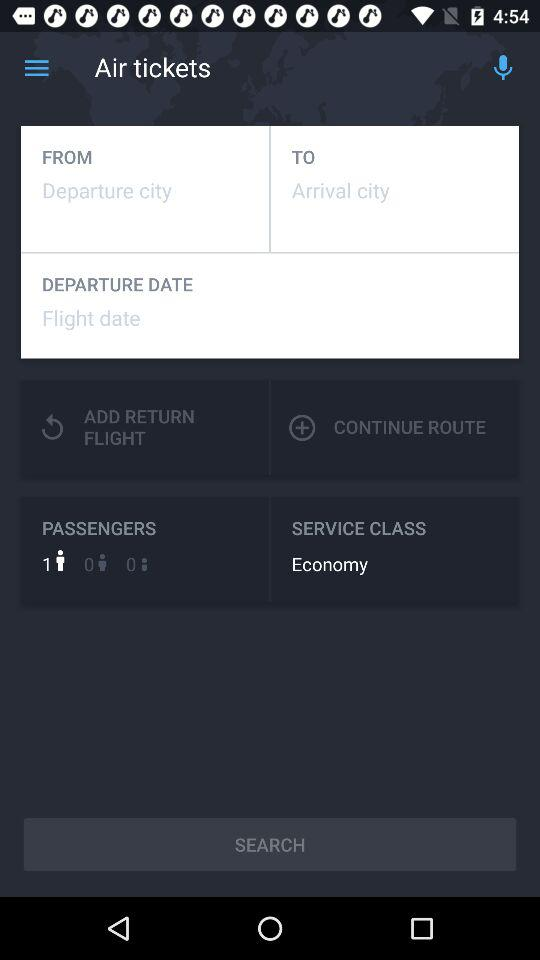Which service class is selected for the tickets? The selected service class is "Economy". 